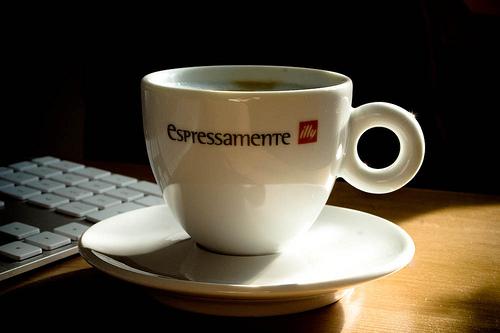Can a man with a big thumb use this tea cup?
Give a very brief answer. No. Is it really safe to position a liquid that close to an electronic device?
Concise answer only. No. What brand keyboard is featured?
Keep it brief. Apple. 